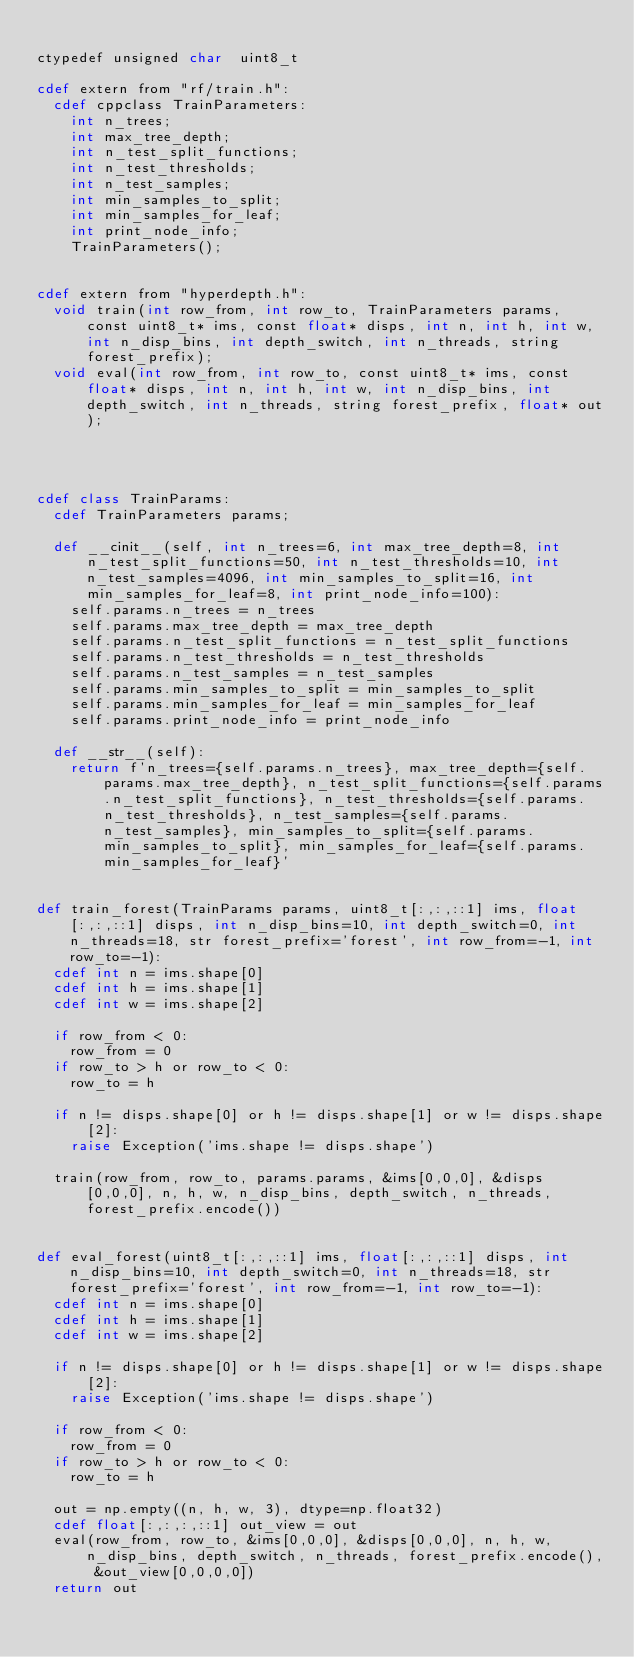Convert code to text. <code><loc_0><loc_0><loc_500><loc_500><_Cython_>
ctypedef unsigned char  uint8_t

cdef extern from "rf/train.h":
  cdef cppclass TrainParameters:
    int n_trees;
    int max_tree_depth;
    int n_test_split_functions;
    int n_test_thresholds;
    int n_test_samples;
    int min_samples_to_split;
    int min_samples_for_leaf;
    int print_node_info;
    TrainParameters();


cdef extern from "hyperdepth.h":
  void train(int row_from, int row_to, TrainParameters params, const uint8_t* ims, const float* disps, int n, int h, int w, int n_disp_bins, int depth_switch, int n_threads, string forest_prefix);
  void eval(int row_from, int row_to, const uint8_t* ims, const float* disps, int n, int h, int w, int n_disp_bins, int depth_switch, int n_threads, string forest_prefix, float* out);
  



cdef class TrainParams:
  cdef TrainParameters params;
  
  def __cinit__(self, int n_trees=6, int max_tree_depth=8, int n_test_split_functions=50, int n_test_thresholds=10, int n_test_samples=4096, int min_samples_to_split=16, int min_samples_for_leaf=8, int print_node_info=100):
    self.params.n_trees = n_trees
    self.params.max_tree_depth = max_tree_depth
    self.params.n_test_split_functions = n_test_split_functions
    self.params.n_test_thresholds = n_test_thresholds
    self.params.n_test_samples = n_test_samples
    self.params.min_samples_to_split = min_samples_to_split
    self.params.min_samples_for_leaf = min_samples_for_leaf
    self.params.print_node_info = print_node_info

  def __str__(self):
    return f'n_trees={self.params.n_trees}, max_tree_depth={self.params.max_tree_depth}, n_test_split_functions={self.params.n_test_split_functions}, n_test_thresholds={self.params.n_test_thresholds}, n_test_samples={self.params.n_test_samples}, min_samples_to_split={self.params.min_samples_to_split}, min_samples_for_leaf={self.params.min_samples_for_leaf}'


def train_forest(TrainParams params, uint8_t[:,:,::1] ims, float[:,:,::1] disps, int n_disp_bins=10, int depth_switch=0, int n_threads=18, str forest_prefix='forest', int row_from=-1, int row_to=-1):
  cdef int n = ims.shape[0]
  cdef int h = ims.shape[1]
  cdef int w = ims.shape[2]

  if row_from < 0:
    row_from = 0
  if row_to > h or row_to < 0:
    row_to = h

  if n != disps.shape[0] or h != disps.shape[1] or w != disps.shape[2]:
    raise Exception('ims.shape != disps.shape')

  train(row_from, row_to, params.params, &ims[0,0,0], &disps[0,0,0], n, h, w, n_disp_bins, depth_switch, n_threads, forest_prefix.encode())


def eval_forest(uint8_t[:,:,::1] ims, float[:,:,::1] disps, int n_disp_bins=10, int depth_switch=0, int n_threads=18, str forest_prefix='forest', int row_from=-1, int row_to=-1):
  cdef int n = ims.shape[0]
  cdef int h = ims.shape[1]
  cdef int w = ims.shape[2]

  if n != disps.shape[0] or h != disps.shape[1] or w != disps.shape[2]:
    raise Exception('ims.shape != disps.shape')

  if row_from < 0:
    row_from = 0
  if row_to > h or row_to < 0:
    row_to = h

  out = np.empty((n, h, w, 3), dtype=np.float32)
  cdef float[:,:,:,::1] out_view = out
  eval(row_from, row_to, &ims[0,0,0], &disps[0,0,0], n, h, w, n_disp_bins, depth_switch, n_threads, forest_prefix.encode(), &out_view[0,0,0,0])
  return out
</code> 